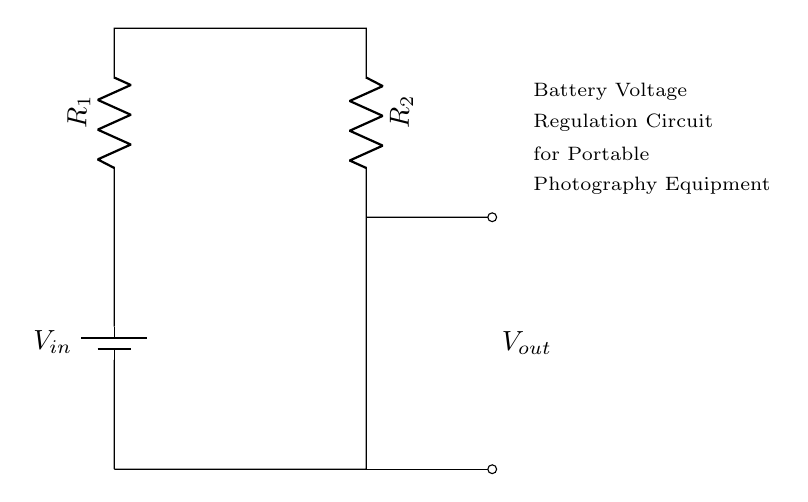What type of circuit is depicted? The circuit is a voltage divider, recognizable by its arrangement of resistors in series that divides the input voltage into smaller output voltages.
Answer: Voltage divider What are the resistors labeled in the diagram? The resistors are labeled R1 and R2, which are the two resistors connected in series that form the voltage divider.
Answer: R1 and R2 What is the purpose of this circuit? The purpose is to regulate battery voltage for portable photography equipment, ensuring that the output voltage is appropriate for the device.
Answer: Voltage regulation What does \( V_{in} \) represent in this circuit? \( V_{in} \) represents the input voltage supplied by the battery in the circuit, providing the necessary power to the voltage divider.
Answer: Battery voltage How is \( V_{out} \) connected in the circuit? \( V_{out} \) is connected at the junction between R1 and R2, indicating that this is where the reduced output voltage is taken from.
Answer: At the junction of R1 and R2 What is the voltage output determined by? The output voltage \( V_{out} \) is determined by the values of R1 and R2, which dictate how the input voltage \( V_{in} \) is divided between them.
Answer: The resistor values R1 and R2 What happens to \( V_{out} \) if R1 increases? If R1 increases, \( V_{out} \) will decrease because more voltage will drop across R1, leading to a smaller proportion of the total voltage appearing across R2.
Answer: \( V_{out} \) decreases 